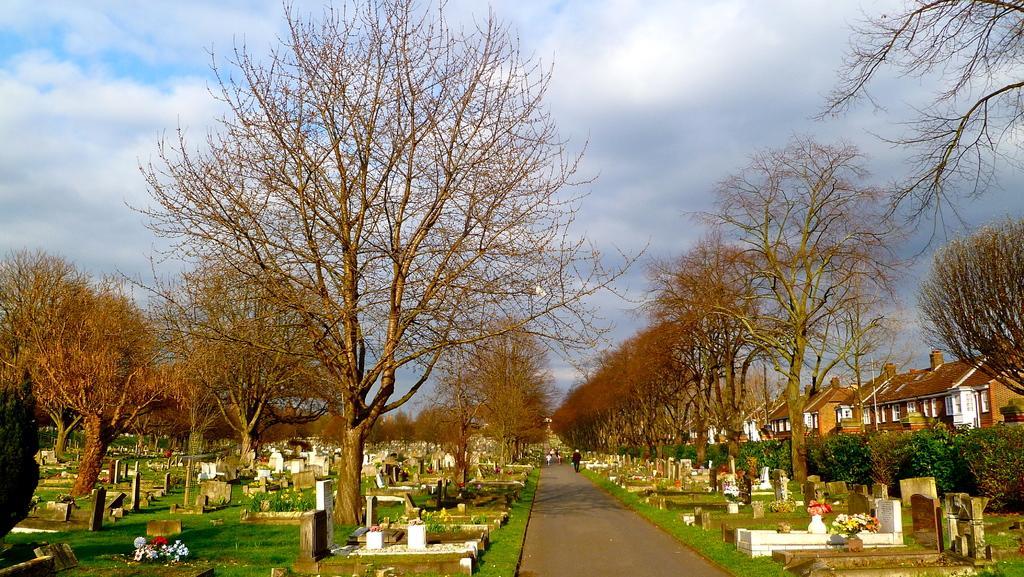Could you give a brief overview of what you see in this image? This is a picture of graveyard. These are bare trees. Here we can see planets and houses. We can see people on the road. At the top we can see sky with clouds. These are flowers. 